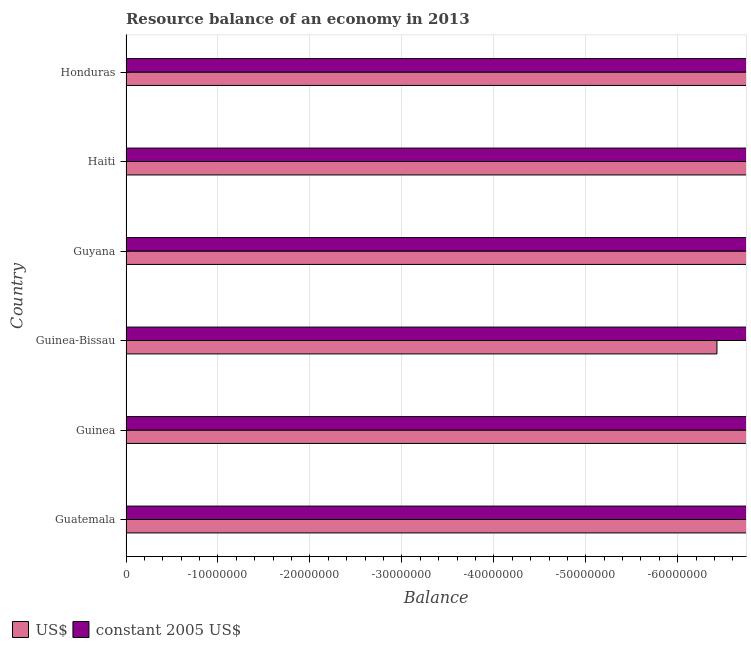Are the number of bars per tick equal to the number of legend labels?
Provide a succinct answer. No. Are the number of bars on each tick of the Y-axis equal?
Give a very brief answer. Yes. How many bars are there on the 4th tick from the top?
Your response must be concise. 0. How many bars are there on the 3rd tick from the bottom?
Make the answer very short. 0. What is the label of the 5th group of bars from the top?
Your response must be concise. Guinea. What is the total resource balance in us$ in the graph?
Keep it short and to the point. 0. What is the average resource balance in constant us$ per country?
Provide a short and direct response. 0. In how many countries, is the resource balance in constant us$ greater than -40000000 units?
Give a very brief answer. 0. In how many countries, is the resource balance in us$ greater than the average resource balance in us$ taken over all countries?
Provide a succinct answer. 0. Are all the bars in the graph horizontal?
Your answer should be compact. Yes. What is the difference between two consecutive major ticks on the X-axis?
Offer a terse response. 1.00e+07. Are the values on the major ticks of X-axis written in scientific E-notation?
Offer a very short reply. No. Does the graph contain any zero values?
Keep it short and to the point. Yes. How many legend labels are there?
Offer a terse response. 2. How are the legend labels stacked?
Give a very brief answer. Horizontal. What is the title of the graph?
Provide a short and direct response. Resource balance of an economy in 2013. Does "Canada" appear as one of the legend labels in the graph?
Offer a terse response. No. What is the label or title of the X-axis?
Ensure brevity in your answer.  Balance. What is the label or title of the Y-axis?
Ensure brevity in your answer.  Country. What is the Balance in US$ in Guyana?
Ensure brevity in your answer.  0. What is the Balance in constant 2005 US$ in Honduras?
Provide a short and direct response. 0. What is the total Balance of US$ in the graph?
Your answer should be compact. 0. What is the average Balance of US$ per country?
Keep it short and to the point. 0. What is the average Balance of constant 2005 US$ per country?
Offer a very short reply. 0. 